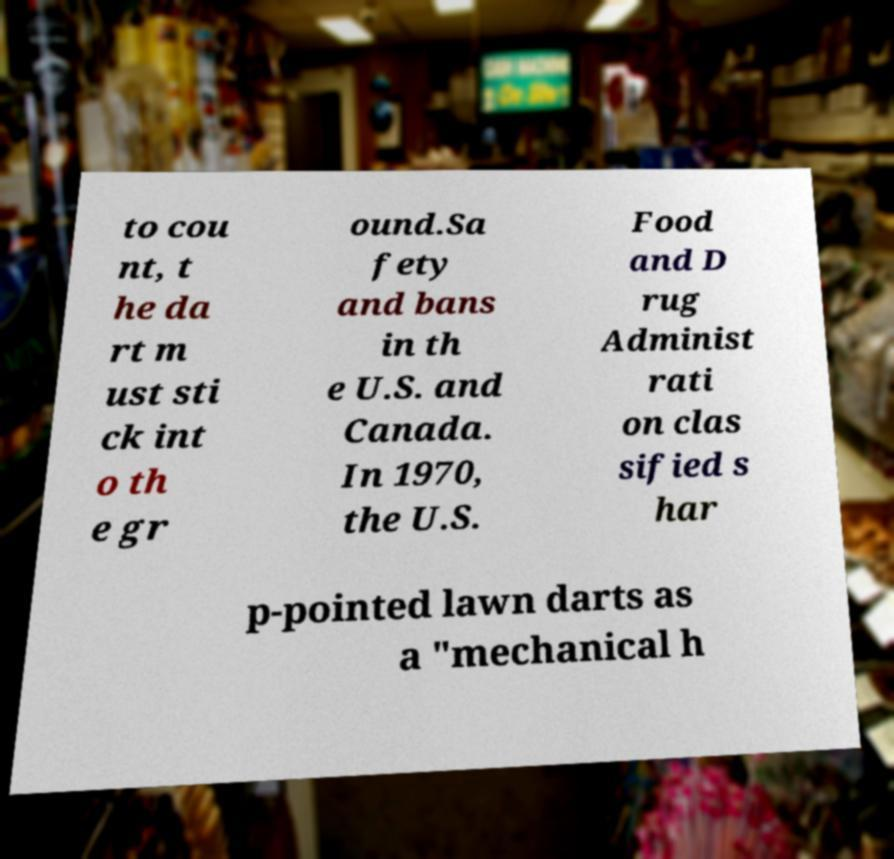I need the written content from this picture converted into text. Can you do that? to cou nt, t he da rt m ust sti ck int o th e gr ound.Sa fety and bans in th e U.S. and Canada. In 1970, the U.S. Food and D rug Administ rati on clas sified s har p-pointed lawn darts as a "mechanical h 